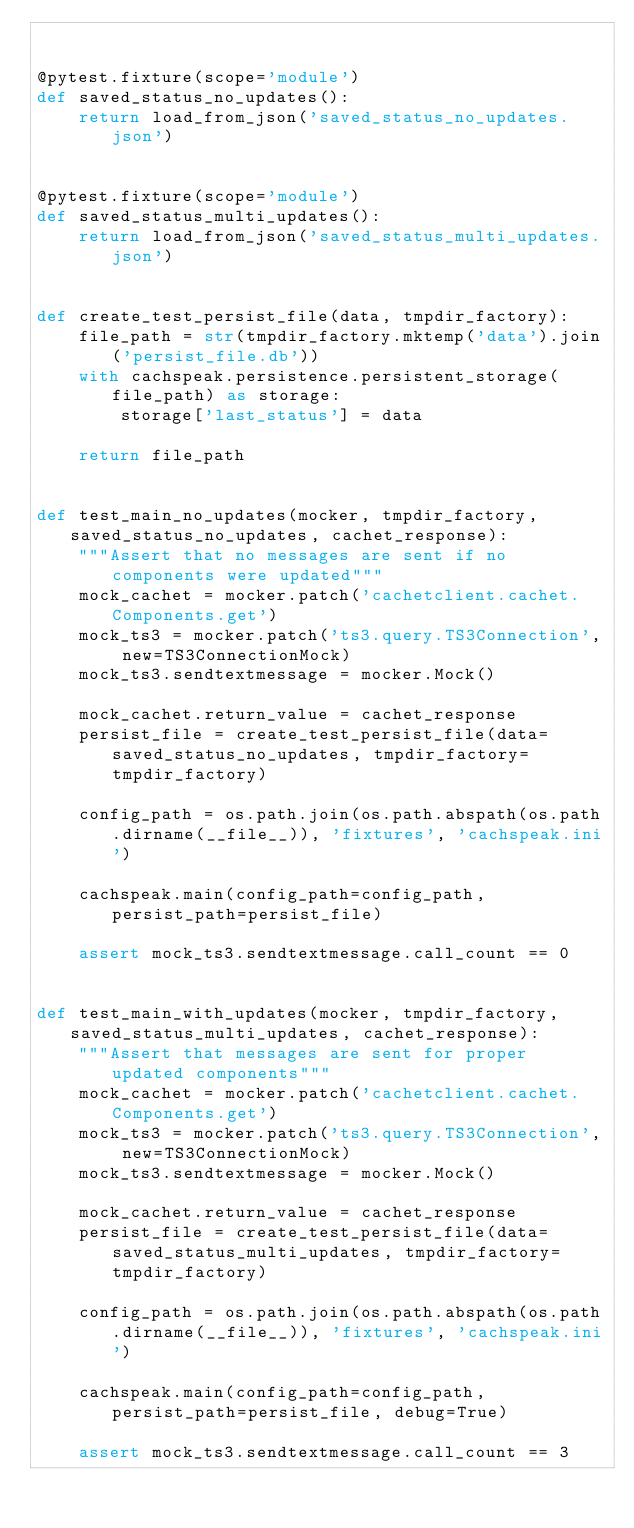Convert code to text. <code><loc_0><loc_0><loc_500><loc_500><_Python_>

@pytest.fixture(scope='module')
def saved_status_no_updates():
    return load_from_json('saved_status_no_updates.json')


@pytest.fixture(scope='module')
def saved_status_multi_updates():
    return load_from_json('saved_status_multi_updates.json')


def create_test_persist_file(data, tmpdir_factory):
    file_path = str(tmpdir_factory.mktemp('data').join('persist_file.db'))
    with cachspeak.persistence.persistent_storage(file_path) as storage:
        storage['last_status'] = data

    return file_path


def test_main_no_updates(mocker, tmpdir_factory, saved_status_no_updates, cachet_response):
    """Assert that no messages are sent if no components were updated"""
    mock_cachet = mocker.patch('cachetclient.cachet.Components.get')
    mock_ts3 = mocker.patch('ts3.query.TS3Connection', new=TS3ConnectionMock)
    mock_ts3.sendtextmessage = mocker.Mock()

    mock_cachet.return_value = cachet_response
    persist_file = create_test_persist_file(data=saved_status_no_updates, tmpdir_factory=tmpdir_factory)

    config_path = os.path.join(os.path.abspath(os.path.dirname(__file__)), 'fixtures', 'cachspeak.ini')

    cachspeak.main(config_path=config_path, persist_path=persist_file)

    assert mock_ts3.sendtextmessage.call_count == 0


def test_main_with_updates(mocker, tmpdir_factory, saved_status_multi_updates, cachet_response):
    """Assert that messages are sent for proper updated components"""
    mock_cachet = mocker.patch('cachetclient.cachet.Components.get')
    mock_ts3 = mocker.patch('ts3.query.TS3Connection', new=TS3ConnectionMock)
    mock_ts3.sendtextmessage = mocker.Mock()

    mock_cachet.return_value = cachet_response
    persist_file = create_test_persist_file(data=saved_status_multi_updates, tmpdir_factory=tmpdir_factory)

    config_path = os.path.join(os.path.abspath(os.path.dirname(__file__)), 'fixtures', 'cachspeak.ini')

    cachspeak.main(config_path=config_path, persist_path=persist_file, debug=True)

    assert mock_ts3.sendtextmessage.call_count == 3
</code> 